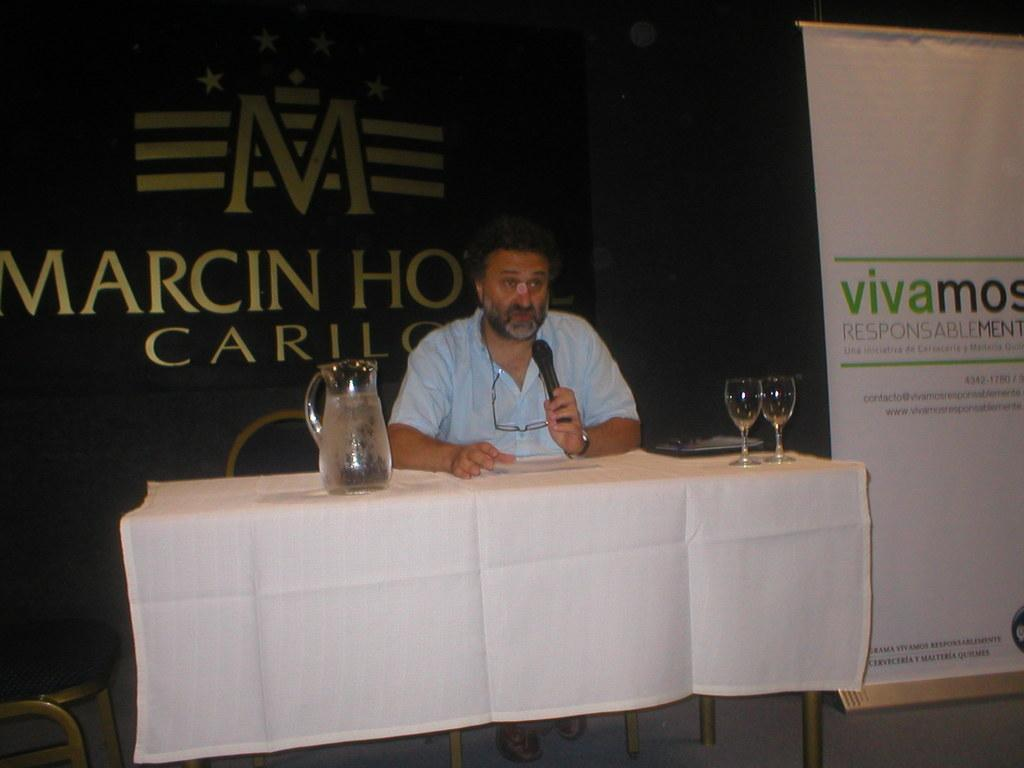Who or what is the main subject in the image? There is a person in the image. What is the person doing in the image? The person is sitting on a chair and holding a microphone in his hand. What is the person sitting in front of? The person is in front of a table. What type of cloth is draped over the person's nose in the image? There is no cloth draped over the person's nose in the image. What kind of flag is visible in the background of the image? There is no flag visible in the image. 